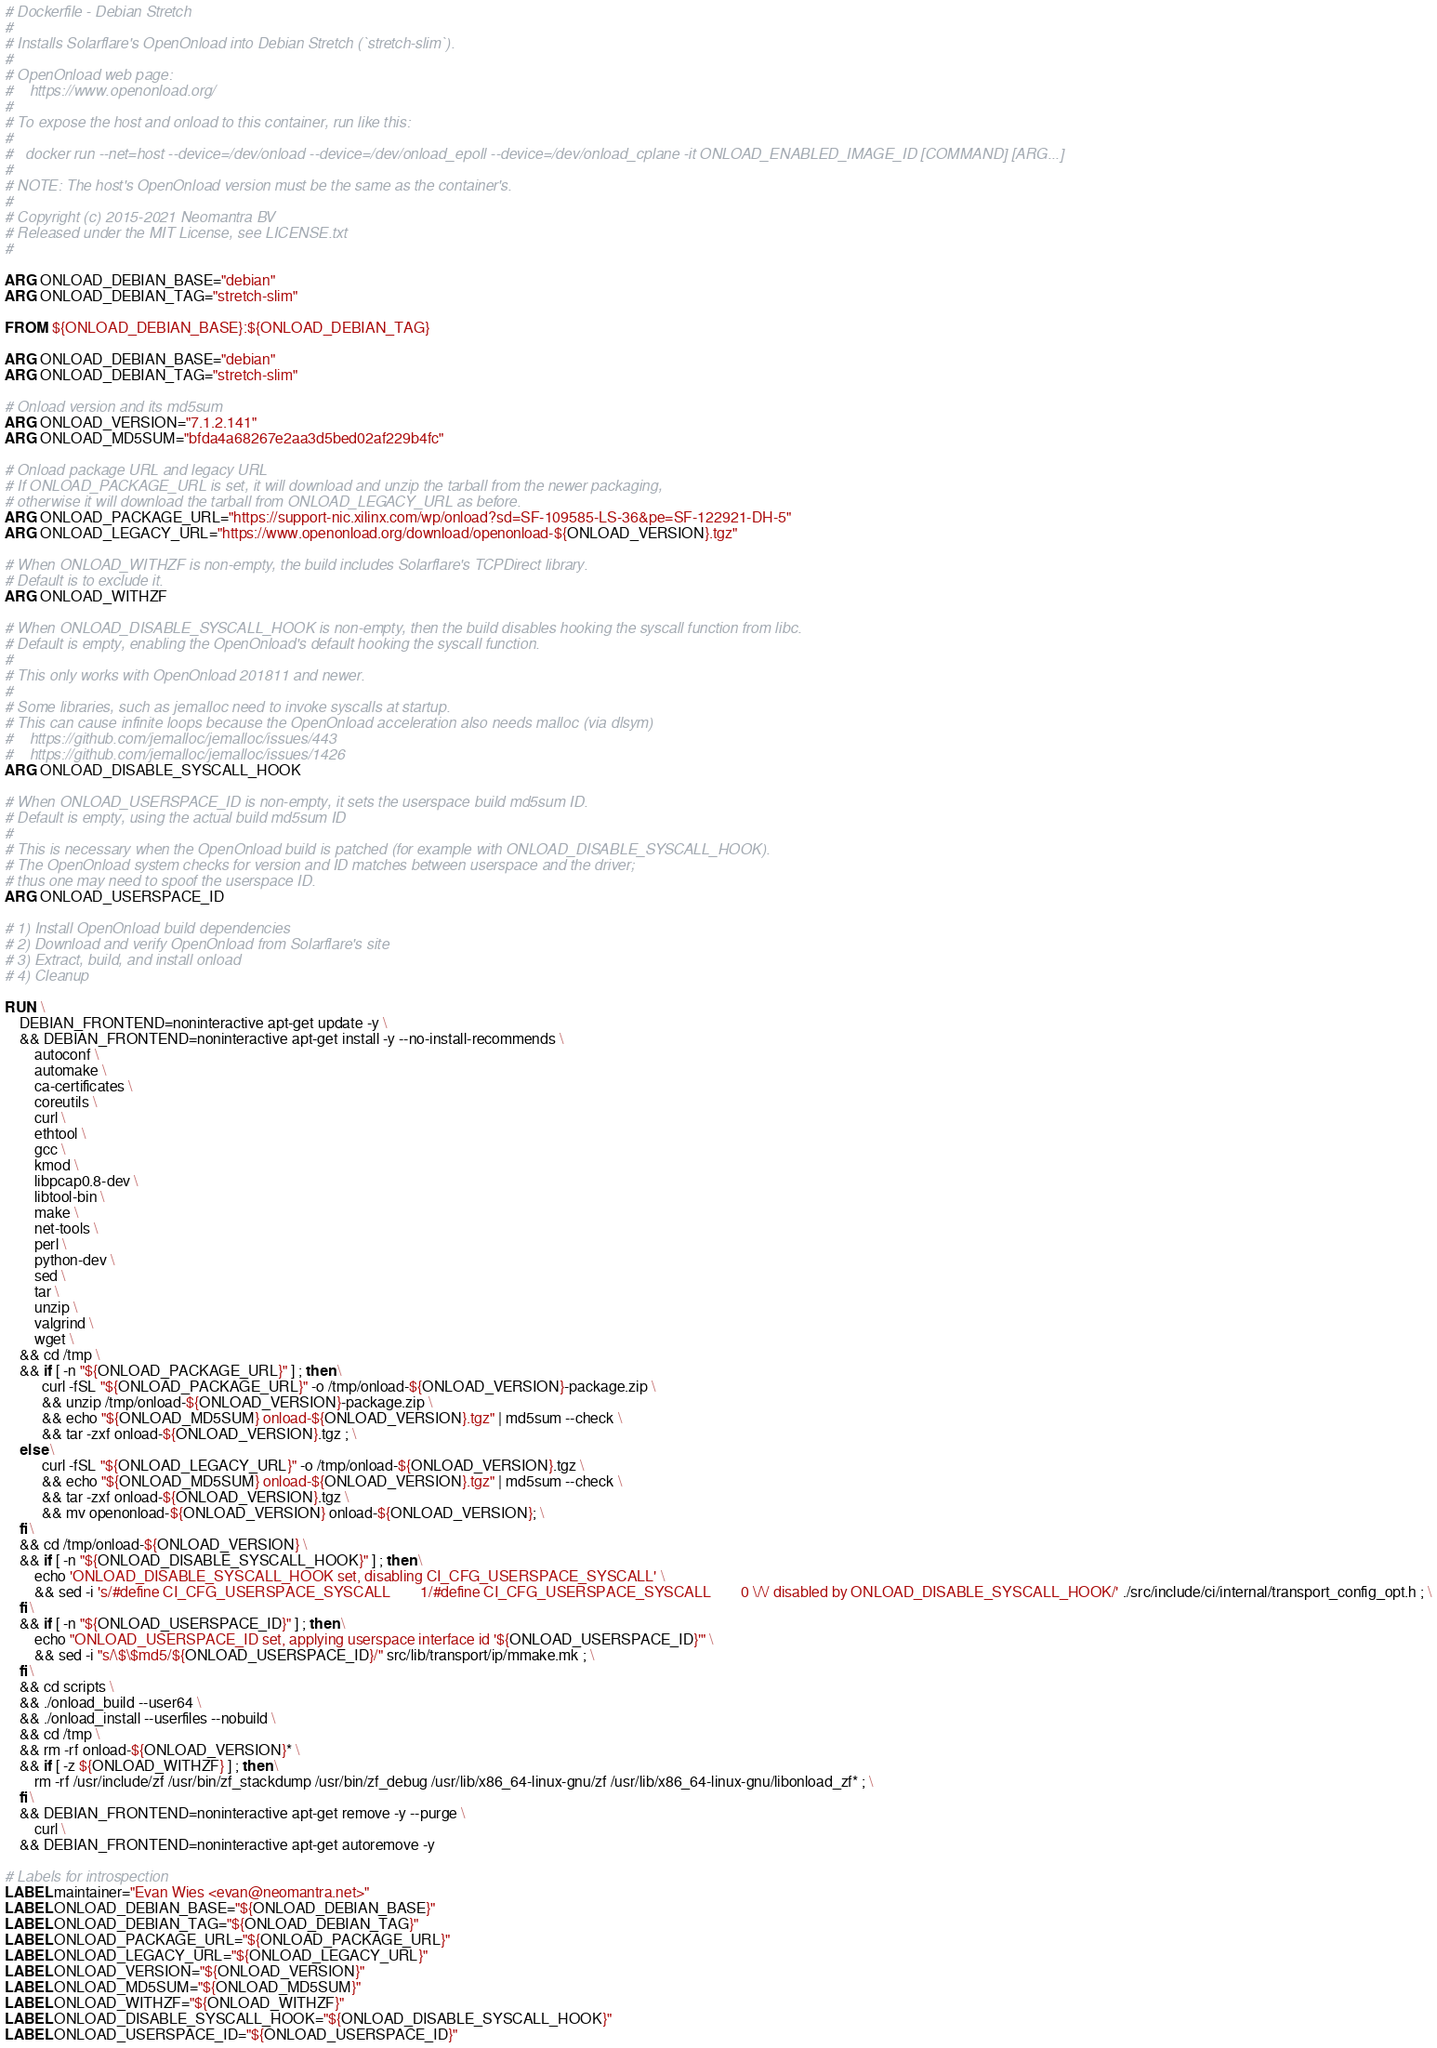Convert code to text. <code><loc_0><loc_0><loc_500><loc_500><_Dockerfile_># Dockerfile - Debian Stretch
#
# Installs Solarflare's OpenOnload into Debian Stretch (`stretch-slim`).
#
# OpenOnload web page:
#    https://www.openonload.org/
#
# To expose the host and onload to this container, run like this:
#
#   docker run --net=host --device=/dev/onload --device=/dev/onload_epoll --device=/dev/onload_cplane -it ONLOAD_ENABLED_IMAGE_ID [COMMAND] [ARG...]
#
# NOTE: The host's OpenOnload version must be the same as the container's.
#
# Copyright (c) 2015-2021 Neomantra BV
# Released under the MIT License, see LICENSE.txt
#

ARG ONLOAD_DEBIAN_BASE="debian"
ARG ONLOAD_DEBIAN_TAG="stretch-slim"

FROM ${ONLOAD_DEBIAN_BASE}:${ONLOAD_DEBIAN_TAG}

ARG ONLOAD_DEBIAN_BASE="debian"
ARG ONLOAD_DEBIAN_TAG="stretch-slim"

# Onload version and its md5sum
ARG ONLOAD_VERSION="7.1.2.141"
ARG ONLOAD_MD5SUM="bfda4a68267e2aa3d5bed02af229b4fc"

# Onload package URL and legacy URL
# If ONLOAD_PACKAGE_URL is set, it will download and unzip the tarball from the newer packaging,
# otherwise it will download the tarball from ONLOAD_LEGACY_URL as before.
ARG ONLOAD_PACKAGE_URL="https://support-nic.xilinx.com/wp/onload?sd=SF-109585-LS-36&pe=SF-122921-DH-5"
ARG ONLOAD_LEGACY_URL="https://www.openonload.org/download/openonload-${ONLOAD_VERSION}.tgz"

# When ONLOAD_WITHZF is non-empty, the build includes Solarflare's TCPDirect library.
# Default is to exclude it.
ARG ONLOAD_WITHZF

# When ONLOAD_DISABLE_SYSCALL_HOOK is non-empty, then the build disables hooking the syscall function from libc.
# Default is empty, enabling the OpenOnload's default hooking the syscall function.
#
# This only works with OpenOnload 201811 and newer.
#
# Some libraries, such as jemalloc need to invoke syscalls at startup.
# This can cause infinite loops because the OpenOnload acceleration also needs malloc (via dlsym)
#    https://github.com/jemalloc/jemalloc/issues/443
#    https://github.com/jemalloc/jemalloc/issues/1426
ARG ONLOAD_DISABLE_SYSCALL_HOOK

# When ONLOAD_USERSPACE_ID is non-empty, it sets the userspace build md5sum ID.
# Default is empty, using the actual build md5sum ID
#
# This is necessary when the OpenOnload build is patched (for example with ONLOAD_DISABLE_SYSCALL_HOOK).
# The OpenOnload system checks for version and ID matches between userspace and the driver;
# thus one may need to spoof the userspace ID.
ARG ONLOAD_USERSPACE_ID

# 1) Install OpenOnload build dependencies
# 2) Download and verify OpenOnload from Solarflare's site
# 3) Extract, build, and install onload
# 4) Cleanup

RUN \
    DEBIAN_FRONTEND=noninteractive apt-get update -y \
    && DEBIAN_FRONTEND=noninteractive apt-get install -y --no-install-recommends \
        autoconf \
        automake \
        ca-certificates \
        coreutils \
        curl \
        ethtool \
        gcc \
        kmod \
        libpcap0.8-dev \
        libtool-bin \
        make \
        net-tools \
        perl \
        python-dev \
        sed \
        tar \
        unzip \
        valgrind \
        wget \
    && cd /tmp \
    && if [ -n "${ONLOAD_PACKAGE_URL}" ] ; then \
          curl -fSL "${ONLOAD_PACKAGE_URL}" -o /tmp/onload-${ONLOAD_VERSION}-package.zip \
          && unzip /tmp/onload-${ONLOAD_VERSION}-package.zip \
          && echo "${ONLOAD_MD5SUM} onload-${ONLOAD_VERSION}.tgz" | md5sum --check \
          && tar -zxf onload-${ONLOAD_VERSION}.tgz ; \
    else \
          curl -fSL "${ONLOAD_LEGACY_URL}" -o /tmp/onload-${ONLOAD_VERSION}.tgz \
          && echo "${ONLOAD_MD5SUM} onload-${ONLOAD_VERSION}.tgz" | md5sum --check \
          && tar -zxf onload-${ONLOAD_VERSION}.tgz \
          && mv openonload-${ONLOAD_VERSION} onload-${ONLOAD_VERSION}; \
    fi \
    && cd /tmp/onload-${ONLOAD_VERSION} \
    && if [ -n "${ONLOAD_DISABLE_SYSCALL_HOOK}" ] ; then \
        echo 'ONLOAD_DISABLE_SYSCALL_HOOK set, disabling CI_CFG_USERSPACE_SYSCALL' \
        && sed -i 's/#define CI_CFG_USERSPACE_SYSCALL        1/#define CI_CFG_USERSPACE_SYSCALL        0 \/\/ disabled by ONLOAD_DISABLE_SYSCALL_HOOK/' ./src/include/ci/internal/transport_config_opt.h ; \
    fi \
    && if [ -n "${ONLOAD_USERSPACE_ID}" ] ; then \
        echo "ONLOAD_USERSPACE_ID set, applying userspace interface id '${ONLOAD_USERSPACE_ID}'" \
        && sed -i "s/\$\$md5/${ONLOAD_USERSPACE_ID}/" src/lib/transport/ip/mmake.mk ; \
    fi \
    && cd scripts \
    && ./onload_build --user64 \
    && ./onload_install --userfiles --nobuild \
    && cd /tmp \
    && rm -rf onload-${ONLOAD_VERSION}* \
    && if [ -z ${ONLOAD_WITHZF} ] ; then \
        rm -rf /usr/include/zf /usr/bin/zf_stackdump /usr/bin/zf_debug /usr/lib/x86_64-linux-gnu/zf /usr/lib/x86_64-linux-gnu/libonload_zf* ; \
    fi \
    && DEBIAN_FRONTEND=noninteractive apt-get remove -y --purge \
        curl \
    && DEBIAN_FRONTEND=noninteractive apt-get autoremove -y

# Labels for introspection
LABEL maintainer="Evan Wies <evan@neomantra.net>"
LABEL ONLOAD_DEBIAN_BASE="${ONLOAD_DEBIAN_BASE}"
LABEL ONLOAD_DEBIAN_TAG="${ONLOAD_DEBIAN_TAG}"
LABEL ONLOAD_PACKAGE_URL="${ONLOAD_PACKAGE_URL}"
LABEL ONLOAD_LEGACY_URL="${ONLOAD_LEGACY_URL}"
LABEL ONLOAD_VERSION="${ONLOAD_VERSION}"
LABEL ONLOAD_MD5SUM="${ONLOAD_MD5SUM}"
LABEL ONLOAD_WITHZF="${ONLOAD_WITHZF}"
LABEL ONLOAD_DISABLE_SYSCALL_HOOK="${ONLOAD_DISABLE_SYSCALL_HOOK}"
LABEL ONLOAD_USERSPACE_ID="${ONLOAD_USERSPACE_ID}"
</code> 